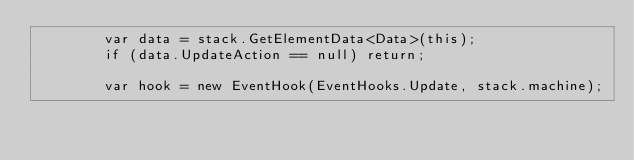Convert code to text. <code><loc_0><loc_0><loc_500><loc_500><_C#_>        var data = stack.GetElementData<Data>(this);
        if (data.UpdateAction == null) return;

        var hook = new EventHook(EventHooks.Update, stack.machine);</code> 